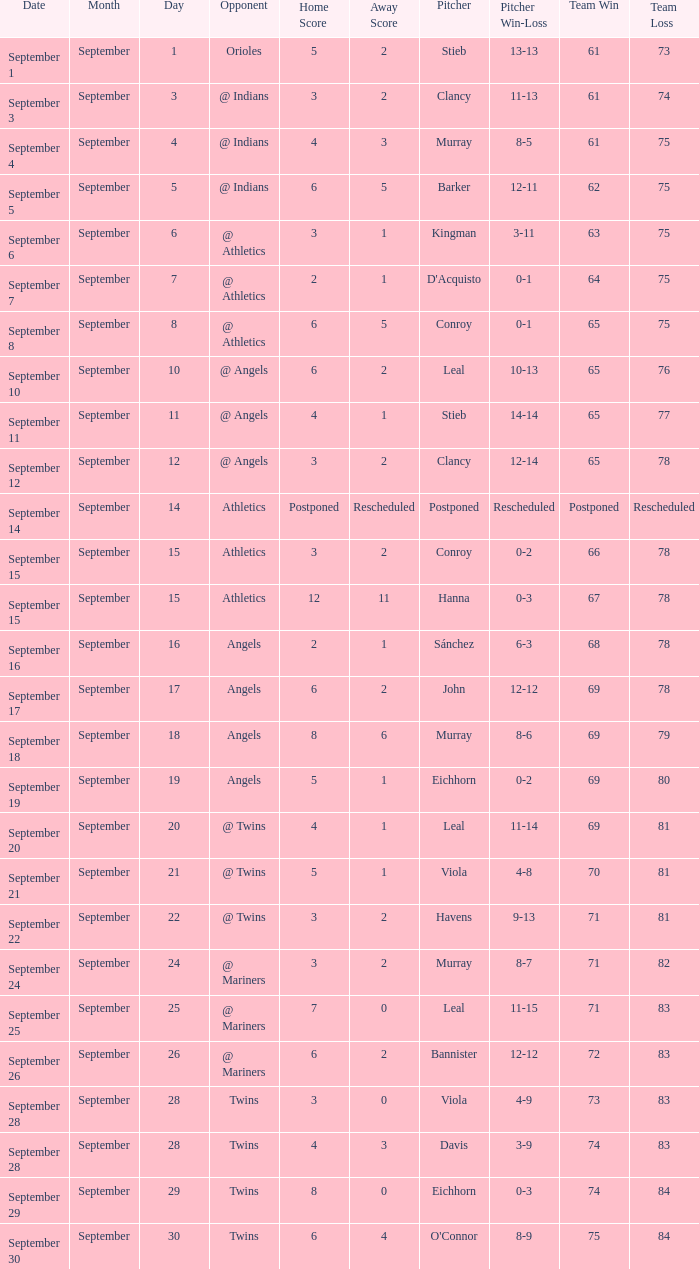Determine the tally for september 11 4 - 1. 